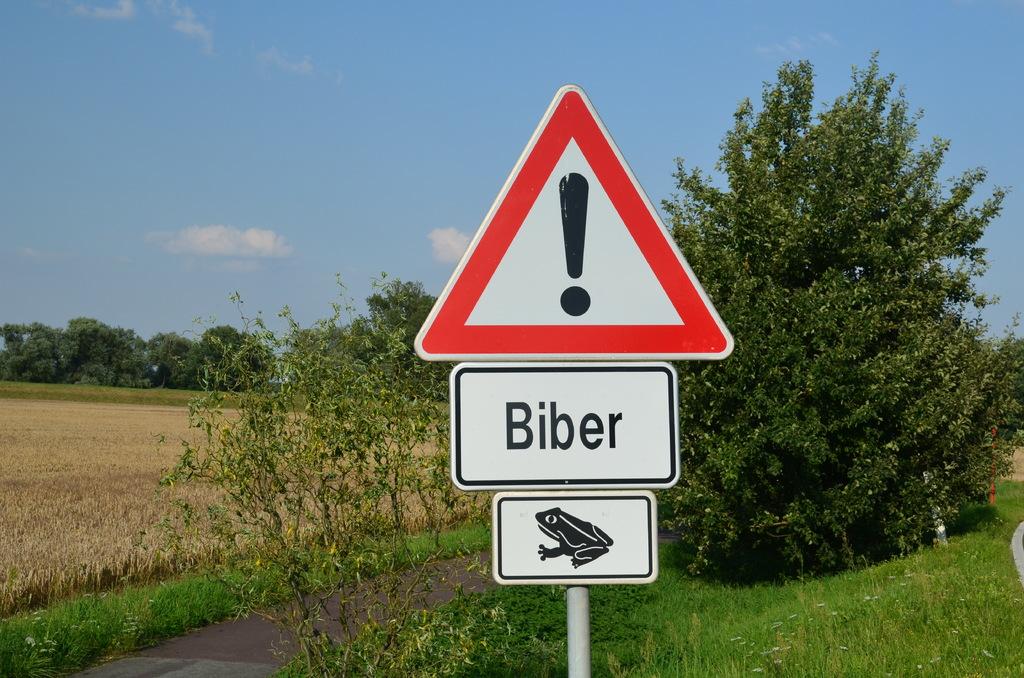What does the sign say?
Provide a succinct answer. Biber. What country is cited on the sign?
Make the answer very short. Biber. 